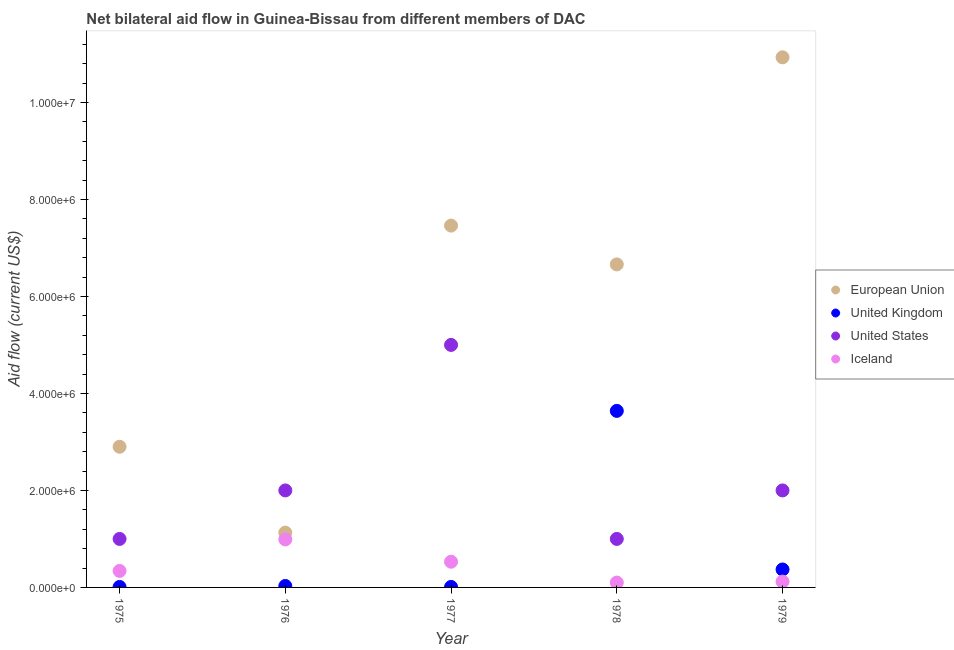What is the amount of aid given by uk in 1979?
Ensure brevity in your answer.  3.70e+05. Across all years, what is the maximum amount of aid given by iceland?
Provide a short and direct response. 9.90e+05. Across all years, what is the minimum amount of aid given by eu?
Offer a terse response. 1.13e+06. In which year was the amount of aid given by us maximum?
Provide a succinct answer. 1977. In which year was the amount of aid given by us minimum?
Provide a succinct answer. 1975. What is the total amount of aid given by uk in the graph?
Keep it short and to the point. 4.06e+06. What is the difference between the amount of aid given by uk in 1975 and that in 1976?
Ensure brevity in your answer.  -2.00e+04. What is the difference between the amount of aid given by uk in 1975 and the amount of aid given by eu in 1979?
Provide a short and direct response. -1.09e+07. What is the average amount of aid given by iceland per year?
Provide a short and direct response. 4.16e+05. In the year 1979, what is the difference between the amount of aid given by eu and amount of aid given by iceland?
Your answer should be very brief. 1.08e+07. In how many years, is the amount of aid given by uk greater than 5600000 US$?
Offer a terse response. 0. What is the ratio of the amount of aid given by uk in 1977 to that in 1979?
Offer a terse response. 0.03. Is the amount of aid given by eu in 1977 less than that in 1979?
Provide a succinct answer. Yes. What is the difference between the highest and the second highest amount of aid given by uk?
Offer a terse response. 3.27e+06. What is the difference between the highest and the lowest amount of aid given by iceland?
Provide a short and direct response. 8.90e+05. In how many years, is the amount of aid given by us greater than the average amount of aid given by us taken over all years?
Keep it short and to the point. 1. Is the amount of aid given by us strictly greater than the amount of aid given by eu over the years?
Your response must be concise. No. Is the amount of aid given by us strictly less than the amount of aid given by iceland over the years?
Provide a succinct answer. No. How many years are there in the graph?
Offer a very short reply. 5. What is the difference between two consecutive major ticks on the Y-axis?
Your answer should be very brief. 2.00e+06. Are the values on the major ticks of Y-axis written in scientific E-notation?
Make the answer very short. Yes. What is the title of the graph?
Provide a short and direct response. Net bilateral aid flow in Guinea-Bissau from different members of DAC. Does "Building human resources" appear as one of the legend labels in the graph?
Provide a succinct answer. No. What is the label or title of the X-axis?
Offer a very short reply. Year. What is the label or title of the Y-axis?
Ensure brevity in your answer.  Aid flow (current US$). What is the Aid flow (current US$) of European Union in 1975?
Your response must be concise. 2.90e+06. What is the Aid flow (current US$) in Iceland in 1975?
Make the answer very short. 3.40e+05. What is the Aid flow (current US$) in European Union in 1976?
Offer a terse response. 1.13e+06. What is the Aid flow (current US$) of United Kingdom in 1976?
Your answer should be compact. 3.00e+04. What is the Aid flow (current US$) of Iceland in 1976?
Your answer should be compact. 9.90e+05. What is the Aid flow (current US$) in European Union in 1977?
Keep it short and to the point. 7.46e+06. What is the Aid flow (current US$) of United States in 1977?
Your response must be concise. 5.00e+06. What is the Aid flow (current US$) in Iceland in 1977?
Your answer should be compact. 5.30e+05. What is the Aid flow (current US$) of European Union in 1978?
Your response must be concise. 6.66e+06. What is the Aid flow (current US$) of United Kingdom in 1978?
Provide a succinct answer. 3.64e+06. What is the Aid flow (current US$) of United States in 1978?
Offer a very short reply. 1.00e+06. What is the Aid flow (current US$) in European Union in 1979?
Your response must be concise. 1.09e+07. What is the Aid flow (current US$) in Iceland in 1979?
Ensure brevity in your answer.  1.20e+05. Across all years, what is the maximum Aid flow (current US$) of European Union?
Offer a very short reply. 1.09e+07. Across all years, what is the maximum Aid flow (current US$) of United Kingdom?
Ensure brevity in your answer.  3.64e+06. Across all years, what is the maximum Aid flow (current US$) in Iceland?
Keep it short and to the point. 9.90e+05. Across all years, what is the minimum Aid flow (current US$) in European Union?
Your response must be concise. 1.13e+06. Across all years, what is the minimum Aid flow (current US$) in United Kingdom?
Provide a short and direct response. 10000. Across all years, what is the minimum Aid flow (current US$) in United States?
Keep it short and to the point. 1.00e+06. Across all years, what is the minimum Aid flow (current US$) of Iceland?
Give a very brief answer. 1.00e+05. What is the total Aid flow (current US$) in European Union in the graph?
Provide a succinct answer. 2.91e+07. What is the total Aid flow (current US$) in United Kingdom in the graph?
Give a very brief answer. 4.06e+06. What is the total Aid flow (current US$) in United States in the graph?
Provide a short and direct response. 1.10e+07. What is the total Aid flow (current US$) in Iceland in the graph?
Ensure brevity in your answer.  2.08e+06. What is the difference between the Aid flow (current US$) of European Union in 1975 and that in 1976?
Offer a very short reply. 1.77e+06. What is the difference between the Aid flow (current US$) in United Kingdom in 1975 and that in 1976?
Offer a terse response. -2.00e+04. What is the difference between the Aid flow (current US$) of United States in 1975 and that in 1976?
Offer a terse response. -1.00e+06. What is the difference between the Aid flow (current US$) in Iceland in 1975 and that in 1976?
Your answer should be compact. -6.50e+05. What is the difference between the Aid flow (current US$) of European Union in 1975 and that in 1977?
Offer a very short reply. -4.56e+06. What is the difference between the Aid flow (current US$) in United States in 1975 and that in 1977?
Provide a short and direct response. -4.00e+06. What is the difference between the Aid flow (current US$) in European Union in 1975 and that in 1978?
Your response must be concise. -3.76e+06. What is the difference between the Aid flow (current US$) in United Kingdom in 1975 and that in 1978?
Provide a succinct answer. -3.63e+06. What is the difference between the Aid flow (current US$) of European Union in 1975 and that in 1979?
Your answer should be compact. -8.03e+06. What is the difference between the Aid flow (current US$) of United Kingdom in 1975 and that in 1979?
Make the answer very short. -3.60e+05. What is the difference between the Aid flow (current US$) in United States in 1975 and that in 1979?
Your answer should be compact. -1.00e+06. What is the difference between the Aid flow (current US$) in European Union in 1976 and that in 1977?
Give a very brief answer. -6.33e+06. What is the difference between the Aid flow (current US$) in United Kingdom in 1976 and that in 1977?
Your answer should be very brief. 2.00e+04. What is the difference between the Aid flow (current US$) in United States in 1976 and that in 1977?
Provide a short and direct response. -3.00e+06. What is the difference between the Aid flow (current US$) in European Union in 1976 and that in 1978?
Ensure brevity in your answer.  -5.53e+06. What is the difference between the Aid flow (current US$) in United Kingdom in 1976 and that in 1978?
Your answer should be compact. -3.61e+06. What is the difference between the Aid flow (current US$) in United States in 1976 and that in 1978?
Keep it short and to the point. 1.00e+06. What is the difference between the Aid flow (current US$) of Iceland in 1976 and that in 1978?
Make the answer very short. 8.90e+05. What is the difference between the Aid flow (current US$) in European Union in 1976 and that in 1979?
Give a very brief answer. -9.80e+06. What is the difference between the Aid flow (current US$) of United States in 1976 and that in 1979?
Your answer should be compact. 0. What is the difference between the Aid flow (current US$) of Iceland in 1976 and that in 1979?
Provide a succinct answer. 8.70e+05. What is the difference between the Aid flow (current US$) in European Union in 1977 and that in 1978?
Offer a terse response. 8.00e+05. What is the difference between the Aid flow (current US$) in United Kingdom in 1977 and that in 1978?
Offer a terse response. -3.63e+06. What is the difference between the Aid flow (current US$) of Iceland in 1977 and that in 1978?
Your answer should be compact. 4.30e+05. What is the difference between the Aid flow (current US$) in European Union in 1977 and that in 1979?
Your answer should be very brief. -3.47e+06. What is the difference between the Aid flow (current US$) of United Kingdom in 1977 and that in 1979?
Your response must be concise. -3.60e+05. What is the difference between the Aid flow (current US$) of Iceland in 1977 and that in 1979?
Your answer should be compact. 4.10e+05. What is the difference between the Aid flow (current US$) in European Union in 1978 and that in 1979?
Your response must be concise. -4.27e+06. What is the difference between the Aid flow (current US$) of United Kingdom in 1978 and that in 1979?
Offer a terse response. 3.27e+06. What is the difference between the Aid flow (current US$) in European Union in 1975 and the Aid flow (current US$) in United Kingdom in 1976?
Provide a succinct answer. 2.87e+06. What is the difference between the Aid flow (current US$) of European Union in 1975 and the Aid flow (current US$) of Iceland in 1976?
Keep it short and to the point. 1.91e+06. What is the difference between the Aid flow (current US$) of United Kingdom in 1975 and the Aid flow (current US$) of United States in 1976?
Keep it short and to the point. -1.99e+06. What is the difference between the Aid flow (current US$) in United Kingdom in 1975 and the Aid flow (current US$) in Iceland in 1976?
Offer a very short reply. -9.80e+05. What is the difference between the Aid flow (current US$) of United States in 1975 and the Aid flow (current US$) of Iceland in 1976?
Offer a very short reply. 10000. What is the difference between the Aid flow (current US$) in European Union in 1975 and the Aid flow (current US$) in United Kingdom in 1977?
Provide a succinct answer. 2.89e+06. What is the difference between the Aid flow (current US$) in European Union in 1975 and the Aid flow (current US$) in United States in 1977?
Offer a very short reply. -2.10e+06. What is the difference between the Aid flow (current US$) of European Union in 1975 and the Aid flow (current US$) of Iceland in 1977?
Give a very brief answer. 2.37e+06. What is the difference between the Aid flow (current US$) in United Kingdom in 1975 and the Aid flow (current US$) in United States in 1977?
Your response must be concise. -4.99e+06. What is the difference between the Aid flow (current US$) in United Kingdom in 1975 and the Aid flow (current US$) in Iceland in 1977?
Provide a short and direct response. -5.20e+05. What is the difference between the Aid flow (current US$) of European Union in 1975 and the Aid flow (current US$) of United Kingdom in 1978?
Provide a short and direct response. -7.40e+05. What is the difference between the Aid flow (current US$) in European Union in 1975 and the Aid flow (current US$) in United States in 1978?
Offer a very short reply. 1.90e+06. What is the difference between the Aid flow (current US$) of European Union in 1975 and the Aid flow (current US$) of Iceland in 1978?
Offer a very short reply. 2.80e+06. What is the difference between the Aid flow (current US$) in United Kingdom in 1975 and the Aid flow (current US$) in United States in 1978?
Make the answer very short. -9.90e+05. What is the difference between the Aid flow (current US$) in United Kingdom in 1975 and the Aid flow (current US$) in Iceland in 1978?
Make the answer very short. -9.00e+04. What is the difference between the Aid flow (current US$) of United States in 1975 and the Aid flow (current US$) of Iceland in 1978?
Provide a succinct answer. 9.00e+05. What is the difference between the Aid flow (current US$) in European Union in 1975 and the Aid flow (current US$) in United Kingdom in 1979?
Your answer should be compact. 2.53e+06. What is the difference between the Aid flow (current US$) of European Union in 1975 and the Aid flow (current US$) of Iceland in 1979?
Your answer should be compact. 2.78e+06. What is the difference between the Aid flow (current US$) in United Kingdom in 1975 and the Aid flow (current US$) in United States in 1979?
Your response must be concise. -1.99e+06. What is the difference between the Aid flow (current US$) of United States in 1975 and the Aid flow (current US$) of Iceland in 1979?
Ensure brevity in your answer.  8.80e+05. What is the difference between the Aid flow (current US$) of European Union in 1976 and the Aid flow (current US$) of United Kingdom in 1977?
Give a very brief answer. 1.12e+06. What is the difference between the Aid flow (current US$) of European Union in 1976 and the Aid flow (current US$) of United States in 1977?
Provide a short and direct response. -3.87e+06. What is the difference between the Aid flow (current US$) of United Kingdom in 1976 and the Aid flow (current US$) of United States in 1977?
Give a very brief answer. -4.97e+06. What is the difference between the Aid flow (current US$) in United Kingdom in 1976 and the Aid flow (current US$) in Iceland in 1977?
Your response must be concise. -5.00e+05. What is the difference between the Aid flow (current US$) of United States in 1976 and the Aid flow (current US$) of Iceland in 1977?
Ensure brevity in your answer.  1.47e+06. What is the difference between the Aid flow (current US$) in European Union in 1976 and the Aid flow (current US$) in United Kingdom in 1978?
Offer a terse response. -2.51e+06. What is the difference between the Aid flow (current US$) of European Union in 1976 and the Aid flow (current US$) of United States in 1978?
Offer a terse response. 1.30e+05. What is the difference between the Aid flow (current US$) in European Union in 1976 and the Aid flow (current US$) in Iceland in 1978?
Make the answer very short. 1.03e+06. What is the difference between the Aid flow (current US$) in United Kingdom in 1976 and the Aid flow (current US$) in United States in 1978?
Make the answer very short. -9.70e+05. What is the difference between the Aid flow (current US$) of United Kingdom in 1976 and the Aid flow (current US$) of Iceland in 1978?
Provide a succinct answer. -7.00e+04. What is the difference between the Aid flow (current US$) of United States in 1976 and the Aid flow (current US$) of Iceland in 1978?
Your answer should be compact. 1.90e+06. What is the difference between the Aid flow (current US$) of European Union in 1976 and the Aid flow (current US$) of United Kingdom in 1979?
Provide a short and direct response. 7.60e+05. What is the difference between the Aid flow (current US$) of European Union in 1976 and the Aid flow (current US$) of United States in 1979?
Provide a short and direct response. -8.70e+05. What is the difference between the Aid flow (current US$) in European Union in 1976 and the Aid flow (current US$) in Iceland in 1979?
Ensure brevity in your answer.  1.01e+06. What is the difference between the Aid flow (current US$) in United Kingdom in 1976 and the Aid flow (current US$) in United States in 1979?
Give a very brief answer. -1.97e+06. What is the difference between the Aid flow (current US$) in United Kingdom in 1976 and the Aid flow (current US$) in Iceland in 1979?
Provide a short and direct response. -9.00e+04. What is the difference between the Aid flow (current US$) in United States in 1976 and the Aid flow (current US$) in Iceland in 1979?
Offer a terse response. 1.88e+06. What is the difference between the Aid flow (current US$) of European Union in 1977 and the Aid flow (current US$) of United Kingdom in 1978?
Your answer should be compact. 3.82e+06. What is the difference between the Aid flow (current US$) in European Union in 1977 and the Aid flow (current US$) in United States in 1978?
Your response must be concise. 6.46e+06. What is the difference between the Aid flow (current US$) of European Union in 1977 and the Aid flow (current US$) of Iceland in 1978?
Provide a succinct answer. 7.36e+06. What is the difference between the Aid flow (current US$) of United Kingdom in 1977 and the Aid flow (current US$) of United States in 1978?
Your response must be concise. -9.90e+05. What is the difference between the Aid flow (current US$) in United States in 1977 and the Aid flow (current US$) in Iceland in 1978?
Ensure brevity in your answer.  4.90e+06. What is the difference between the Aid flow (current US$) in European Union in 1977 and the Aid flow (current US$) in United Kingdom in 1979?
Ensure brevity in your answer.  7.09e+06. What is the difference between the Aid flow (current US$) in European Union in 1977 and the Aid flow (current US$) in United States in 1979?
Offer a terse response. 5.46e+06. What is the difference between the Aid flow (current US$) of European Union in 1977 and the Aid flow (current US$) of Iceland in 1979?
Ensure brevity in your answer.  7.34e+06. What is the difference between the Aid flow (current US$) of United Kingdom in 1977 and the Aid flow (current US$) of United States in 1979?
Ensure brevity in your answer.  -1.99e+06. What is the difference between the Aid flow (current US$) in United States in 1977 and the Aid flow (current US$) in Iceland in 1979?
Your response must be concise. 4.88e+06. What is the difference between the Aid flow (current US$) of European Union in 1978 and the Aid flow (current US$) of United Kingdom in 1979?
Your answer should be very brief. 6.29e+06. What is the difference between the Aid flow (current US$) of European Union in 1978 and the Aid flow (current US$) of United States in 1979?
Provide a succinct answer. 4.66e+06. What is the difference between the Aid flow (current US$) in European Union in 1978 and the Aid flow (current US$) in Iceland in 1979?
Your answer should be very brief. 6.54e+06. What is the difference between the Aid flow (current US$) in United Kingdom in 1978 and the Aid flow (current US$) in United States in 1979?
Make the answer very short. 1.64e+06. What is the difference between the Aid flow (current US$) of United Kingdom in 1978 and the Aid flow (current US$) of Iceland in 1979?
Your answer should be very brief. 3.52e+06. What is the difference between the Aid flow (current US$) in United States in 1978 and the Aid flow (current US$) in Iceland in 1979?
Make the answer very short. 8.80e+05. What is the average Aid flow (current US$) in European Union per year?
Provide a succinct answer. 5.82e+06. What is the average Aid flow (current US$) of United Kingdom per year?
Make the answer very short. 8.12e+05. What is the average Aid flow (current US$) of United States per year?
Give a very brief answer. 2.20e+06. What is the average Aid flow (current US$) of Iceland per year?
Provide a succinct answer. 4.16e+05. In the year 1975, what is the difference between the Aid flow (current US$) in European Union and Aid flow (current US$) in United Kingdom?
Give a very brief answer. 2.89e+06. In the year 1975, what is the difference between the Aid flow (current US$) in European Union and Aid flow (current US$) in United States?
Your response must be concise. 1.90e+06. In the year 1975, what is the difference between the Aid flow (current US$) of European Union and Aid flow (current US$) of Iceland?
Your answer should be very brief. 2.56e+06. In the year 1975, what is the difference between the Aid flow (current US$) in United Kingdom and Aid flow (current US$) in United States?
Your answer should be very brief. -9.90e+05. In the year 1975, what is the difference between the Aid flow (current US$) in United Kingdom and Aid flow (current US$) in Iceland?
Your answer should be very brief. -3.30e+05. In the year 1975, what is the difference between the Aid flow (current US$) in United States and Aid flow (current US$) in Iceland?
Make the answer very short. 6.60e+05. In the year 1976, what is the difference between the Aid flow (current US$) of European Union and Aid flow (current US$) of United Kingdom?
Give a very brief answer. 1.10e+06. In the year 1976, what is the difference between the Aid flow (current US$) of European Union and Aid flow (current US$) of United States?
Provide a short and direct response. -8.70e+05. In the year 1976, what is the difference between the Aid flow (current US$) of European Union and Aid flow (current US$) of Iceland?
Provide a succinct answer. 1.40e+05. In the year 1976, what is the difference between the Aid flow (current US$) of United Kingdom and Aid flow (current US$) of United States?
Keep it short and to the point. -1.97e+06. In the year 1976, what is the difference between the Aid flow (current US$) of United Kingdom and Aid flow (current US$) of Iceland?
Your answer should be compact. -9.60e+05. In the year 1976, what is the difference between the Aid flow (current US$) in United States and Aid flow (current US$) in Iceland?
Your answer should be compact. 1.01e+06. In the year 1977, what is the difference between the Aid flow (current US$) in European Union and Aid flow (current US$) in United Kingdom?
Keep it short and to the point. 7.45e+06. In the year 1977, what is the difference between the Aid flow (current US$) in European Union and Aid flow (current US$) in United States?
Your answer should be compact. 2.46e+06. In the year 1977, what is the difference between the Aid flow (current US$) of European Union and Aid flow (current US$) of Iceland?
Your answer should be compact. 6.93e+06. In the year 1977, what is the difference between the Aid flow (current US$) of United Kingdom and Aid flow (current US$) of United States?
Keep it short and to the point. -4.99e+06. In the year 1977, what is the difference between the Aid flow (current US$) in United Kingdom and Aid flow (current US$) in Iceland?
Give a very brief answer. -5.20e+05. In the year 1977, what is the difference between the Aid flow (current US$) in United States and Aid flow (current US$) in Iceland?
Your answer should be compact. 4.47e+06. In the year 1978, what is the difference between the Aid flow (current US$) of European Union and Aid flow (current US$) of United Kingdom?
Ensure brevity in your answer.  3.02e+06. In the year 1978, what is the difference between the Aid flow (current US$) in European Union and Aid flow (current US$) in United States?
Provide a succinct answer. 5.66e+06. In the year 1978, what is the difference between the Aid flow (current US$) in European Union and Aid flow (current US$) in Iceland?
Provide a short and direct response. 6.56e+06. In the year 1978, what is the difference between the Aid flow (current US$) of United Kingdom and Aid flow (current US$) of United States?
Offer a terse response. 2.64e+06. In the year 1978, what is the difference between the Aid flow (current US$) of United Kingdom and Aid flow (current US$) of Iceland?
Your answer should be compact. 3.54e+06. In the year 1978, what is the difference between the Aid flow (current US$) of United States and Aid flow (current US$) of Iceland?
Give a very brief answer. 9.00e+05. In the year 1979, what is the difference between the Aid flow (current US$) of European Union and Aid flow (current US$) of United Kingdom?
Ensure brevity in your answer.  1.06e+07. In the year 1979, what is the difference between the Aid flow (current US$) of European Union and Aid flow (current US$) of United States?
Give a very brief answer. 8.93e+06. In the year 1979, what is the difference between the Aid flow (current US$) of European Union and Aid flow (current US$) of Iceland?
Offer a terse response. 1.08e+07. In the year 1979, what is the difference between the Aid flow (current US$) in United Kingdom and Aid flow (current US$) in United States?
Offer a very short reply. -1.63e+06. In the year 1979, what is the difference between the Aid flow (current US$) of United Kingdom and Aid flow (current US$) of Iceland?
Provide a short and direct response. 2.50e+05. In the year 1979, what is the difference between the Aid flow (current US$) of United States and Aid flow (current US$) of Iceland?
Your answer should be very brief. 1.88e+06. What is the ratio of the Aid flow (current US$) in European Union in 1975 to that in 1976?
Offer a very short reply. 2.57. What is the ratio of the Aid flow (current US$) of Iceland in 1975 to that in 1976?
Offer a very short reply. 0.34. What is the ratio of the Aid flow (current US$) of European Union in 1975 to that in 1977?
Your response must be concise. 0.39. What is the ratio of the Aid flow (current US$) in Iceland in 1975 to that in 1977?
Your answer should be very brief. 0.64. What is the ratio of the Aid flow (current US$) of European Union in 1975 to that in 1978?
Make the answer very short. 0.44. What is the ratio of the Aid flow (current US$) in United Kingdom in 1975 to that in 1978?
Keep it short and to the point. 0. What is the ratio of the Aid flow (current US$) in United States in 1975 to that in 1978?
Provide a short and direct response. 1. What is the ratio of the Aid flow (current US$) in European Union in 1975 to that in 1979?
Ensure brevity in your answer.  0.27. What is the ratio of the Aid flow (current US$) in United Kingdom in 1975 to that in 1979?
Your response must be concise. 0.03. What is the ratio of the Aid flow (current US$) of United States in 1975 to that in 1979?
Ensure brevity in your answer.  0.5. What is the ratio of the Aid flow (current US$) of Iceland in 1975 to that in 1979?
Provide a succinct answer. 2.83. What is the ratio of the Aid flow (current US$) in European Union in 1976 to that in 1977?
Keep it short and to the point. 0.15. What is the ratio of the Aid flow (current US$) of United Kingdom in 1976 to that in 1977?
Give a very brief answer. 3. What is the ratio of the Aid flow (current US$) in Iceland in 1976 to that in 1977?
Offer a terse response. 1.87. What is the ratio of the Aid flow (current US$) of European Union in 1976 to that in 1978?
Provide a short and direct response. 0.17. What is the ratio of the Aid flow (current US$) in United Kingdom in 1976 to that in 1978?
Your answer should be compact. 0.01. What is the ratio of the Aid flow (current US$) in Iceland in 1976 to that in 1978?
Your answer should be compact. 9.9. What is the ratio of the Aid flow (current US$) in European Union in 1976 to that in 1979?
Provide a succinct answer. 0.1. What is the ratio of the Aid flow (current US$) in United Kingdom in 1976 to that in 1979?
Provide a short and direct response. 0.08. What is the ratio of the Aid flow (current US$) in Iceland in 1976 to that in 1979?
Give a very brief answer. 8.25. What is the ratio of the Aid flow (current US$) of European Union in 1977 to that in 1978?
Your answer should be compact. 1.12. What is the ratio of the Aid flow (current US$) in United Kingdom in 1977 to that in 1978?
Offer a terse response. 0. What is the ratio of the Aid flow (current US$) in United States in 1977 to that in 1978?
Make the answer very short. 5. What is the ratio of the Aid flow (current US$) of Iceland in 1977 to that in 1978?
Your answer should be compact. 5.3. What is the ratio of the Aid flow (current US$) of European Union in 1977 to that in 1979?
Your answer should be compact. 0.68. What is the ratio of the Aid flow (current US$) of United Kingdom in 1977 to that in 1979?
Offer a very short reply. 0.03. What is the ratio of the Aid flow (current US$) in Iceland in 1977 to that in 1979?
Provide a short and direct response. 4.42. What is the ratio of the Aid flow (current US$) in European Union in 1978 to that in 1979?
Your response must be concise. 0.61. What is the ratio of the Aid flow (current US$) in United Kingdom in 1978 to that in 1979?
Your response must be concise. 9.84. What is the ratio of the Aid flow (current US$) in United States in 1978 to that in 1979?
Offer a terse response. 0.5. What is the difference between the highest and the second highest Aid flow (current US$) in European Union?
Ensure brevity in your answer.  3.47e+06. What is the difference between the highest and the second highest Aid flow (current US$) in United Kingdom?
Make the answer very short. 3.27e+06. What is the difference between the highest and the second highest Aid flow (current US$) in United States?
Ensure brevity in your answer.  3.00e+06. What is the difference between the highest and the second highest Aid flow (current US$) of Iceland?
Offer a terse response. 4.60e+05. What is the difference between the highest and the lowest Aid flow (current US$) in European Union?
Your answer should be compact. 9.80e+06. What is the difference between the highest and the lowest Aid flow (current US$) in United Kingdom?
Provide a short and direct response. 3.63e+06. What is the difference between the highest and the lowest Aid flow (current US$) of United States?
Make the answer very short. 4.00e+06. What is the difference between the highest and the lowest Aid flow (current US$) in Iceland?
Provide a succinct answer. 8.90e+05. 